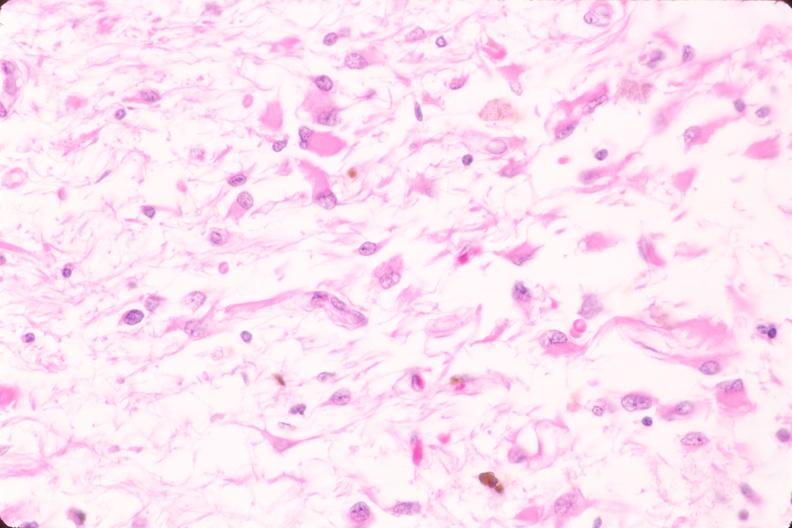where is this?
Answer the question using a single word or phrase. Nervous 